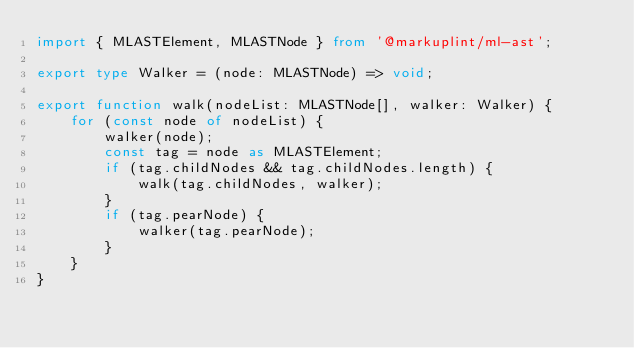<code> <loc_0><loc_0><loc_500><loc_500><_TypeScript_>import { MLASTElement, MLASTNode } from '@markuplint/ml-ast';

export type Walker = (node: MLASTNode) => void;

export function walk(nodeList: MLASTNode[], walker: Walker) {
	for (const node of nodeList) {
		walker(node);
		const tag = node as MLASTElement;
		if (tag.childNodes && tag.childNodes.length) {
			walk(tag.childNodes, walker);
		}
		if (tag.pearNode) {
			walker(tag.pearNode);
		}
	}
}
</code> 